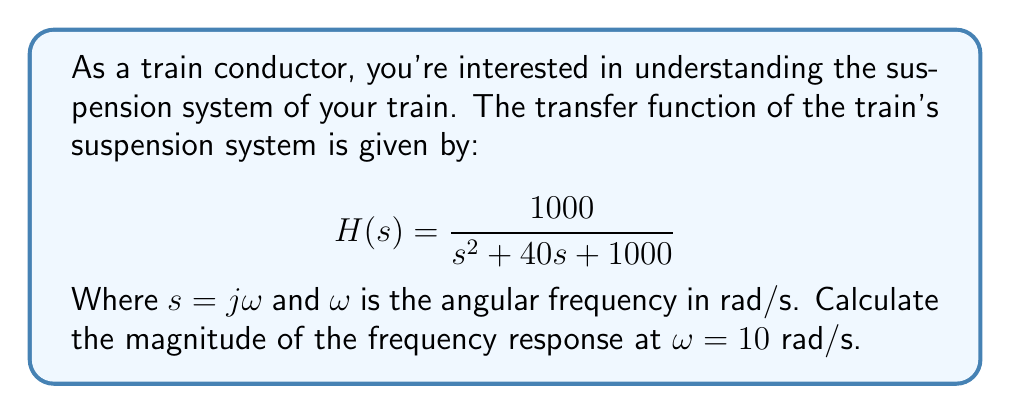What is the answer to this math problem? To solve this problem, we'll follow these steps:

1) First, we substitute $s = j\omega$ into the transfer function:

   $$H(j\omega) = \frac{1000}{(j\omega)^2 + 40(j\omega) + 1000}$$

2) Now, we substitute $\omega = 10$:

   $$H(j10) = \frac{1000}{(j10)^2 + 40(j10) + 1000}$$

3) Simplify the denominator:

   $$H(j10) = \frac{1000}{-100 + 400j + 1000}$$
   
   $$H(j10) = \frac{1000}{900 + 400j}$$

4) To find the magnitude, we use the formula $|H(j\omega)| = \sqrt{\text{Re}^2 + \text{Im}^2}$, where Re is the real part and Im is the imaginary part of the complex number in the denominator.

5) First, we need to rationalize the denominator:

   $$|H(j10)| = \left|\frac{1000}{900 + 400j} \cdot \frac{900 - 400j}{900 - 400j}\right| = \left|\frac{900000 - 400000j}{900^2 + 400^2}\right|$$

6) Now we can separate the real and imaginary parts:

   $$\text{Re} = \frac{900000}{900^2 + 400^2}, \quad \text{Im} = \frac{-400000}{900^2 + 400^2}$$

7) Apply the magnitude formula:

   $$|H(j10)| = \sqrt{\left(\frac{900000}{900^2 + 400^2}\right)^2 + \left(\frac{-400000}{900^2 + 400^2}\right)^2}$$

8) Simplify:

   $$|H(j10)| = \sqrt{\frac{900000^2 + 400000^2}{(900^2 + 400^2)^2}} = \frac{\sqrt{900000^2 + 400000^2}}{900^2 + 400^2}$$

9) Calculate the final result:

   $$|H(j10)| = \frac{1000000}{1000000} = 1$$
Answer: The magnitude of the frequency response at $\omega = 10$ rad/s is 1. 